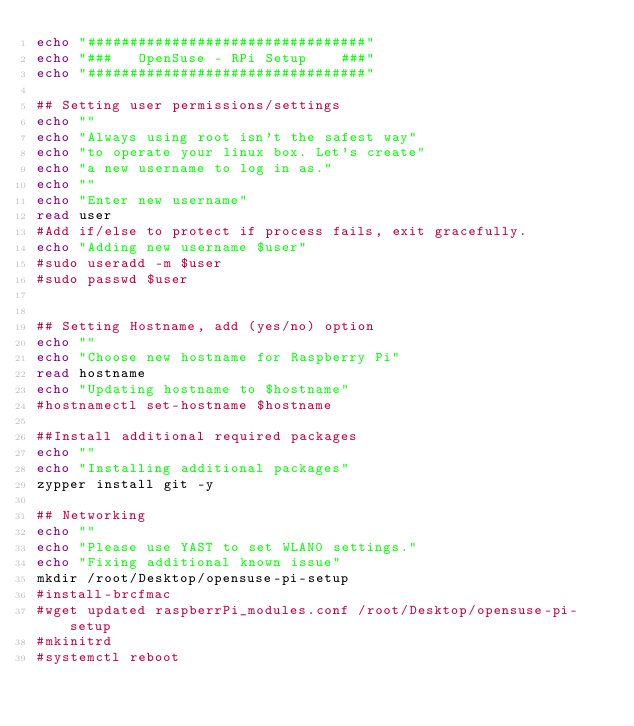Convert code to text. <code><loc_0><loc_0><loc_500><loc_500><_Bash_>echo "#################################"
echo "###   OpenSuse - RPi Setup    ###"
echo "#################################"

## Setting user permissions/settings
echo ""
echo "Always using root isn't the safest way"
echo "to operate your linux box. Let's create"
echo "a new username to log in as."
echo "" 
echo "Enter new username"
read user
#Add if/else to protect if process fails, exit gracefully.
echo "Adding new username $user"
#sudo useradd -m $user
#sudo passwd $user


## Setting Hostname, add (yes/no) option
echo ""
echo "Choose new hostname for Raspberry Pi"
read hostname
echo "Updating hostname to $hostname"
#hostnamectl set-hostname $hostname

##Install additional required packages
echo ""
echo "Installing additional packages" 
zypper install git -y

## Networking
echo "" 
echo "Please use YAST to set WLAN0 settings."
echo "Fixing additional known issue"
mkdir /root/Desktop/opensuse-pi-setup 
#install-brcfmac
#wget updated raspberrPi_modules.conf /root/Desktop/opensuse-pi-setup
#mkinitrd
#systemctl reboot


</code> 